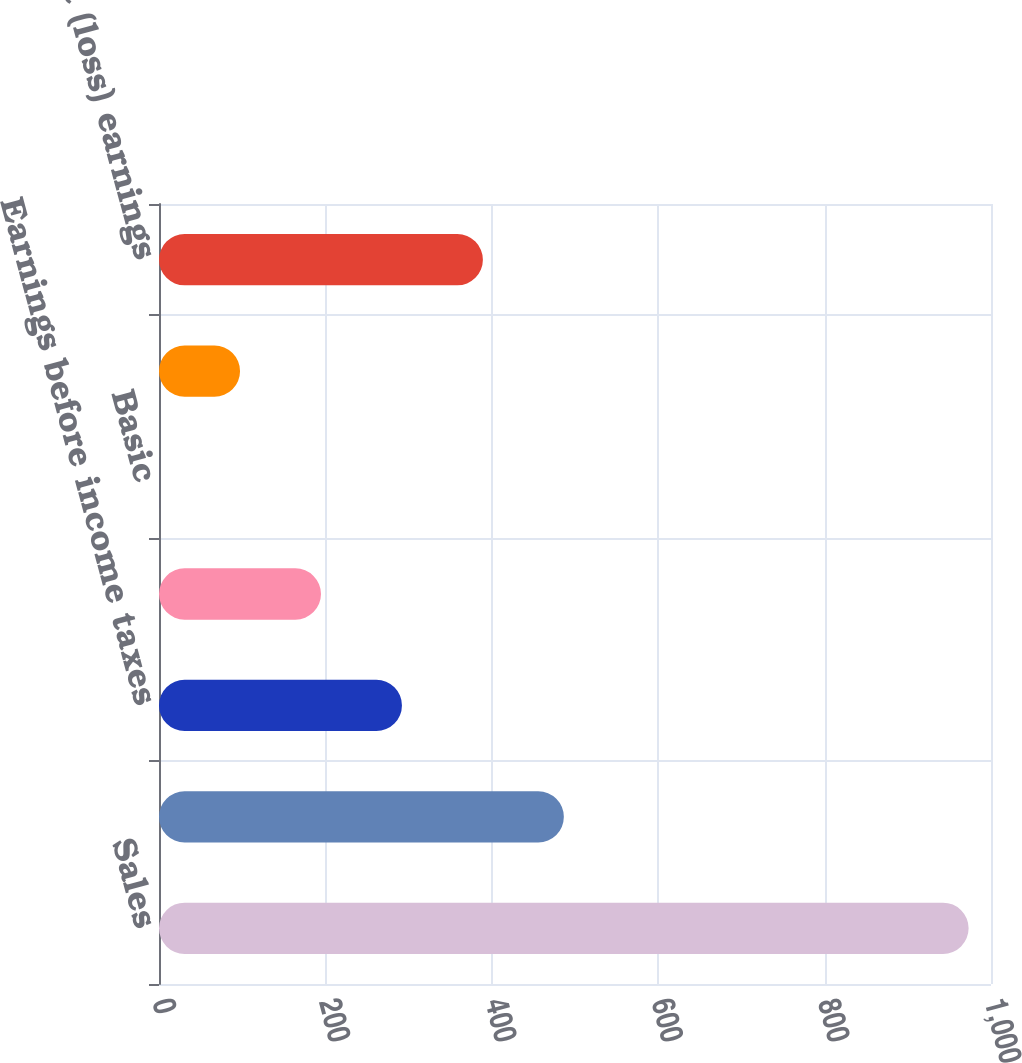Convert chart. <chart><loc_0><loc_0><loc_500><loc_500><bar_chart><fcel>Sales<fcel>Gross profit<fcel>Earnings before income taxes<fcel>Net earnings attributable to<fcel>Basic<fcel>Diluted<fcel>Net (loss) earnings<nl><fcel>973.1<fcel>486.6<fcel>292<fcel>194.7<fcel>0.1<fcel>97.4<fcel>389.3<nl></chart> 